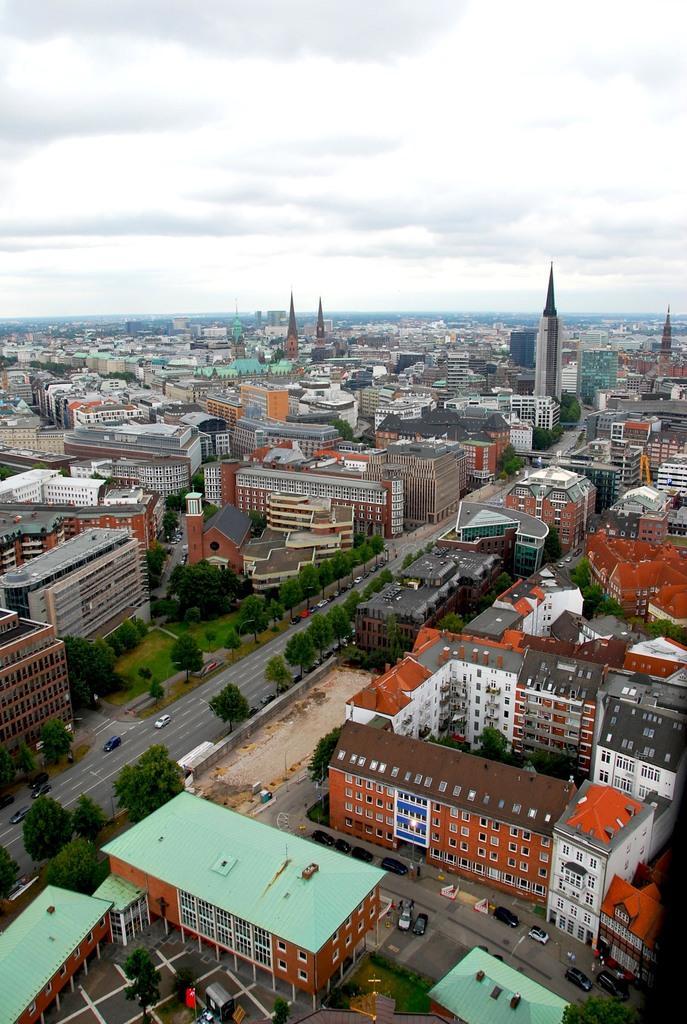Could you give a brief overview of what you see in this image? This is an aerial view, in this image there are houses, towers, buildings, cars, roads, trees and the sky are visible. 